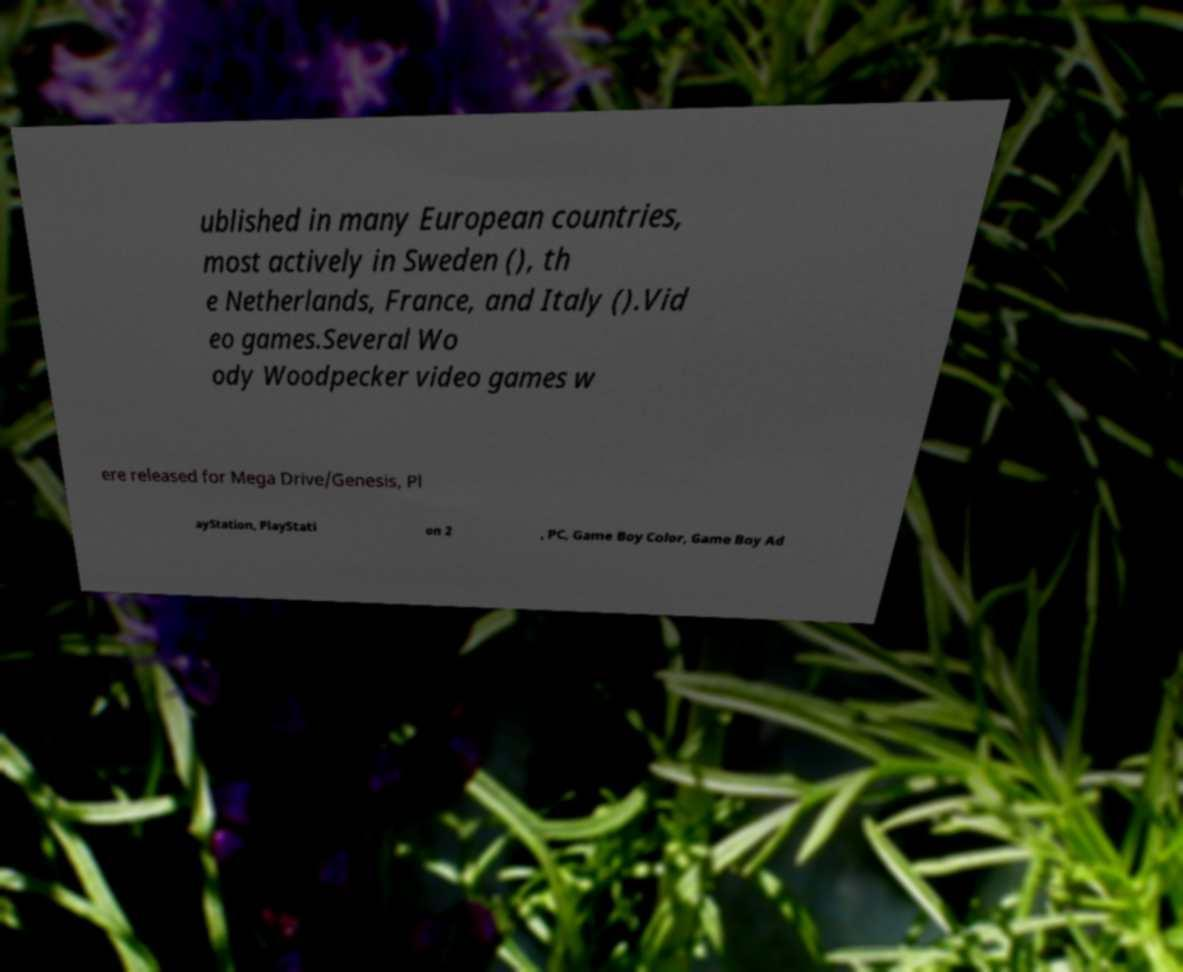Please read and relay the text visible in this image. What does it say? ublished in many European countries, most actively in Sweden (), th e Netherlands, France, and Italy ().Vid eo games.Several Wo ody Woodpecker video games w ere released for Mega Drive/Genesis, Pl ayStation, PlayStati on 2 , PC, Game Boy Color, Game Boy Ad 